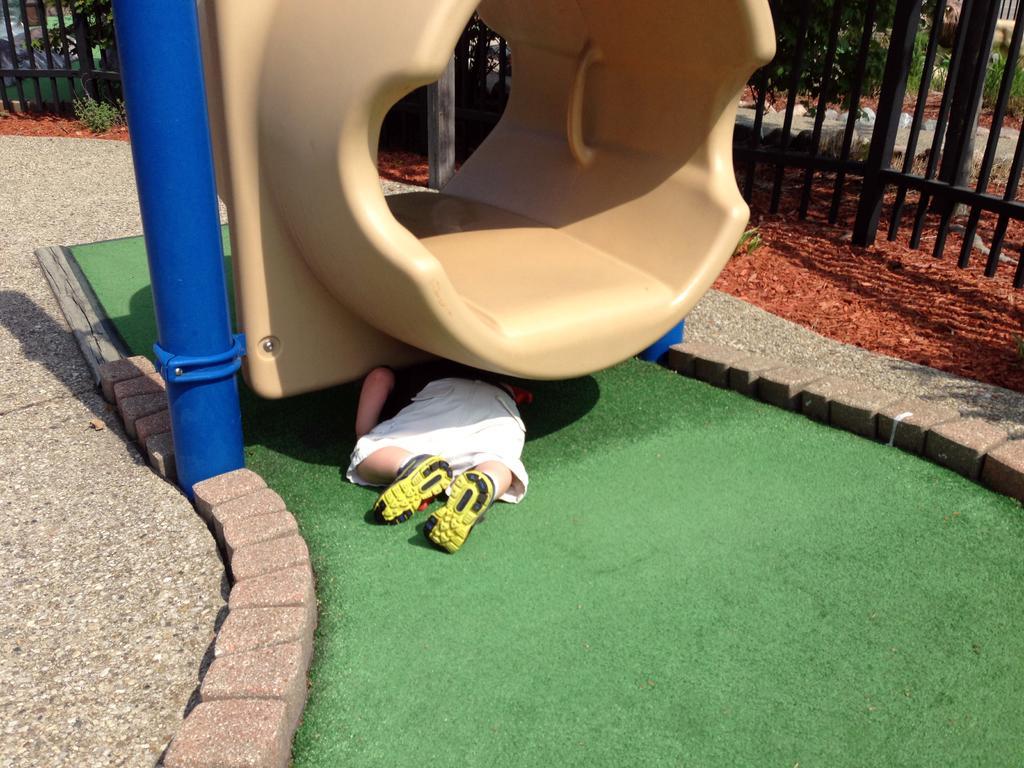Can you describe this image briefly? In this image I can see the person lying and the person is wearing white color short. In front I can see some object in cream and green color, background I can see the railing and I can see few plants in green color. 